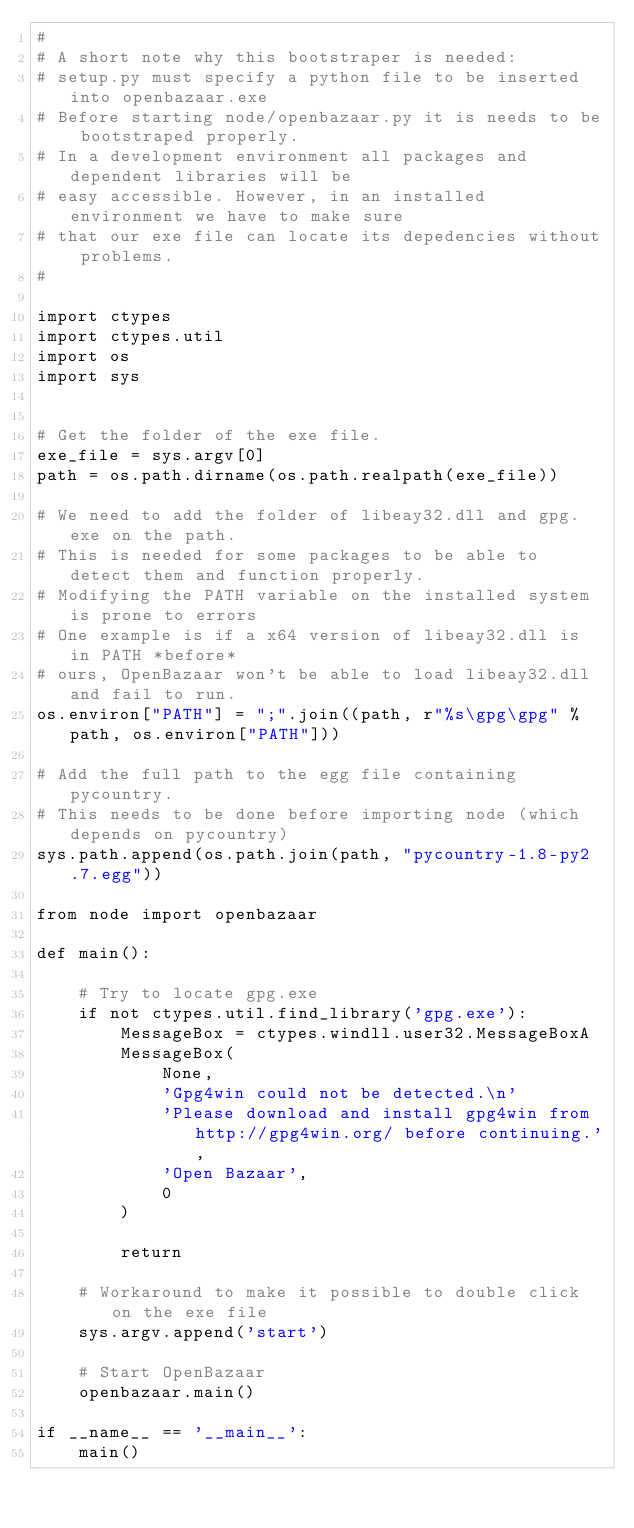<code> <loc_0><loc_0><loc_500><loc_500><_Python_>#
# A short note why this bootstraper is needed:
# setup.py must specify a python file to be inserted into openbazaar.exe
# Before starting node/openbazaar.py it is needs to be bootstraped properly.
# In a development environment all packages and dependent libraries will be
# easy accessible. However, in an installed environment we have to make sure
# that our exe file can locate its depedencies without problems.
#

import ctypes
import ctypes.util
import os
import sys


# Get the folder of the exe file.
exe_file = sys.argv[0]
path = os.path.dirname(os.path.realpath(exe_file))

# We need to add the folder of libeay32.dll and gpg.exe on the path.
# This is needed for some packages to be able to detect them and function properly.
# Modifying the PATH variable on the installed system is prone to errors
# One example is if a x64 version of libeay32.dll is in PATH *before*
# ours, OpenBazaar won't be able to load libeay32.dll and fail to run.
os.environ["PATH"] = ";".join((path, r"%s\gpg\gpg" % path, os.environ["PATH"]))

# Add the full path to the egg file containing pycountry.
# This needs to be done before importing node (which depends on pycountry)
sys.path.append(os.path.join(path, "pycountry-1.8-py2.7.egg"))

from node import openbazaar

def main():

    # Try to locate gpg.exe
    if not ctypes.util.find_library('gpg.exe'):
        MessageBox = ctypes.windll.user32.MessageBoxA
        MessageBox(
            None,
            'Gpg4win could not be detected.\n'
            'Please download and install gpg4win from http://gpg4win.org/ before continuing.',
            'Open Bazaar',
            0
        )

        return

    # Workaround to make it possible to double click on the exe file
    sys.argv.append('start')

    # Start OpenBazaar
    openbazaar.main()

if __name__ == '__main__':
    main()
</code> 